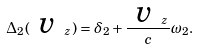Convert formula to latex. <formula><loc_0><loc_0><loc_500><loc_500>\Delta _ { 2 } ( \emph { v } _ { z } ) = \delta _ { 2 } + \frac { \emph { v } _ { z } } { c } \omega _ { 2 } .</formula> 